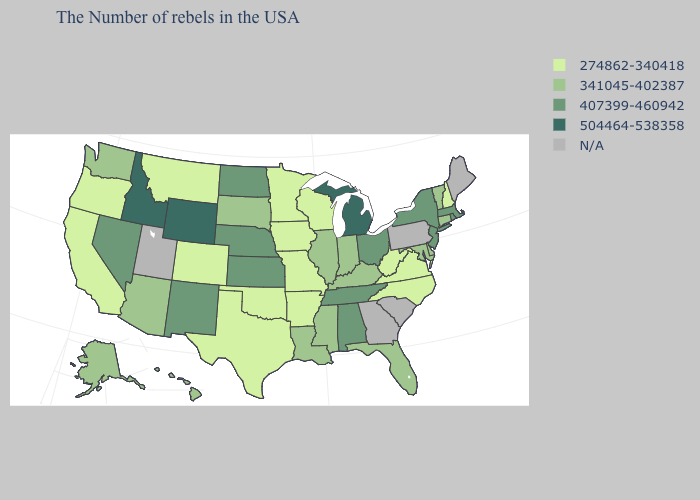Which states have the lowest value in the USA?
Quick response, please. New Hampshire, Virginia, North Carolina, West Virginia, Wisconsin, Missouri, Arkansas, Minnesota, Iowa, Oklahoma, Texas, Colorado, Montana, California, Oregon. Name the states that have a value in the range 504464-538358?
Quick response, please. Michigan, Wyoming, Idaho. What is the value of Kentucky?
Be succinct. 341045-402387. Name the states that have a value in the range 274862-340418?
Short answer required. New Hampshire, Virginia, North Carolina, West Virginia, Wisconsin, Missouri, Arkansas, Minnesota, Iowa, Oklahoma, Texas, Colorado, Montana, California, Oregon. Does Hawaii have the lowest value in the West?
Concise answer only. No. Does Rhode Island have the highest value in the USA?
Write a very short answer. No. Name the states that have a value in the range 274862-340418?
Short answer required. New Hampshire, Virginia, North Carolina, West Virginia, Wisconsin, Missouri, Arkansas, Minnesota, Iowa, Oklahoma, Texas, Colorado, Montana, California, Oregon. Is the legend a continuous bar?
Answer briefly. No. Name the states that have a value in the range 504464-538358?
Answer briefly. Michigan, Wyoming, Idaho. What is the value of Louisiana?
Quick response, please. 341045-402387. Name the states that have a value in the range 504464-538358?
Answer briefly. Michigan, Wyoming, Idaho. Name the states that have a value in the range 341045-402387?
Write a very short answer. Vermont, Connecticut, Delaware, Maryland, Florida, Kentucky, Indiana, Illinois, Mississippi, Louisiana, South Dakota, Arizona, Washington, Alaska, Hawaii. What is the value of North Carolina?
Give a very brief answer. 274862-340418. Does New York have the lowest value in the Northeast?
Quick response, please. No. What is the value of Wisconsin?
Short answer required. 274862-340418. 